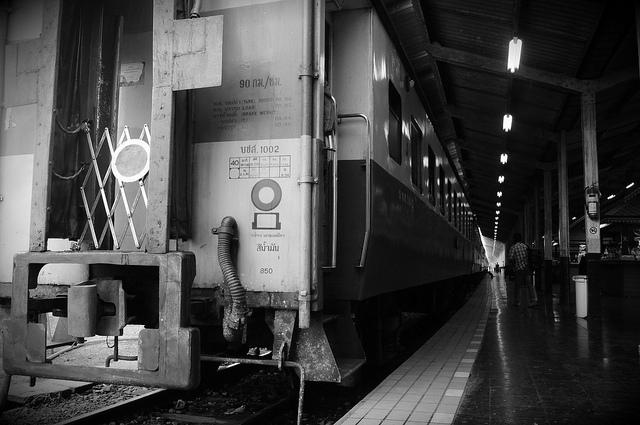Is the photo black and white?
Keep it brief. Yes. Where is this scene?
Short answer required. Train station. What kind of lights are in the picture?
Give a very brief answer. Fluorescent. 